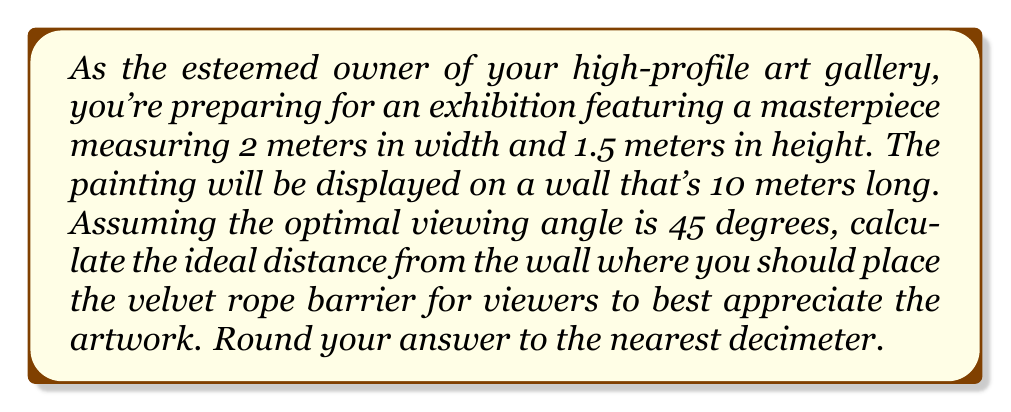Could you help me with this problem? Let's approach this step-by-step:

1) The optimal viewing distance is determined by the painting's largest dimension and the desired viewing angle. In this case, the width (2 meters) is the largest dimension.

2) We can use the tangent function to relate the viewing distance to the painting's width and the viewing angle:

   $$\tan(\theta) = \frac{\text{opposite}}{\text{adjacent}} = \frac{\text{half of painting width}}{\text{viewing distance}}$$

3) We're given that the optimal viewing angle $\theta = 45°$. We know that $\tan(45°) = 1$.

4) Let's call the viewing distance $d$. We can set up the equation:

   $$1 = \frac{1}{d}$$

   Where 1 meter is half the painting's width.

5) Solving for $d$:

   $$d = 1 \text{ meter}$$

6) This means the optimal viewing distance is equal to the painting's width, which is 2 meters.

7) To verify, we can check if this allows the entire painting to fit within the 45° viewing angle:

   $$\tan(45°) = \frac{\text{half of painting height}}{2} = \frac{0.75}{2} = 0.375$$

   Indeed, $0.375 < 1$, so the entire height fits within the angle.

8) Rounding to the nearest decimeter:

   2 meters = 20 decimeters

Therefore, the velvet rope should be placed 20 decimeters (2 meters) from the wall.
Answer: 20 decimeters 